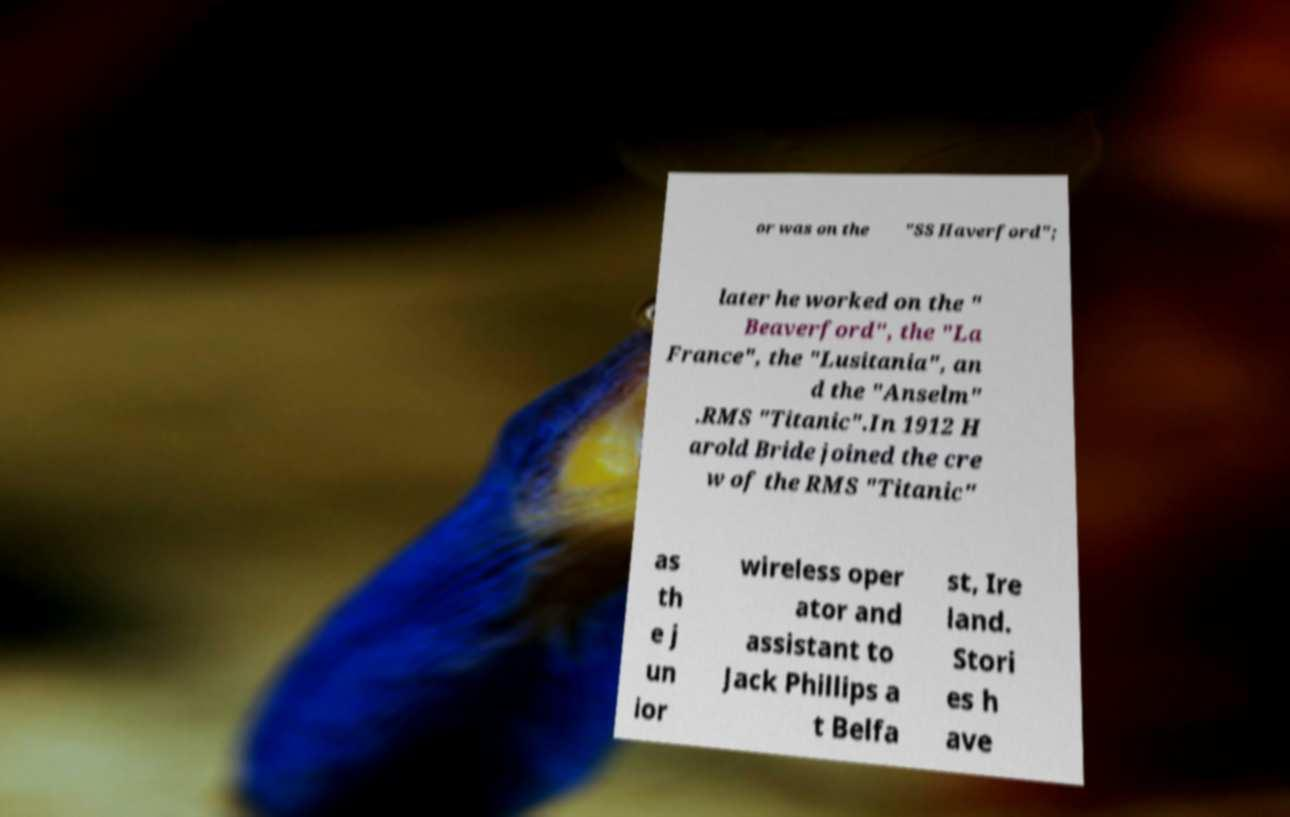Can you accurately transcribe the text from the provided image for me? or was on the "SS Haverford"; later he worked on the " Beaverford", the "La France", the "Lusitania", an d the "Anselm" .RMS "Titanic".In 1912 H arold Bride joined the cre w of the RMS "Titanic" as th e j un ior wireless oper ator and assistant to Jack Phillips a t Belfa st, Ire land. Stori es h ave 